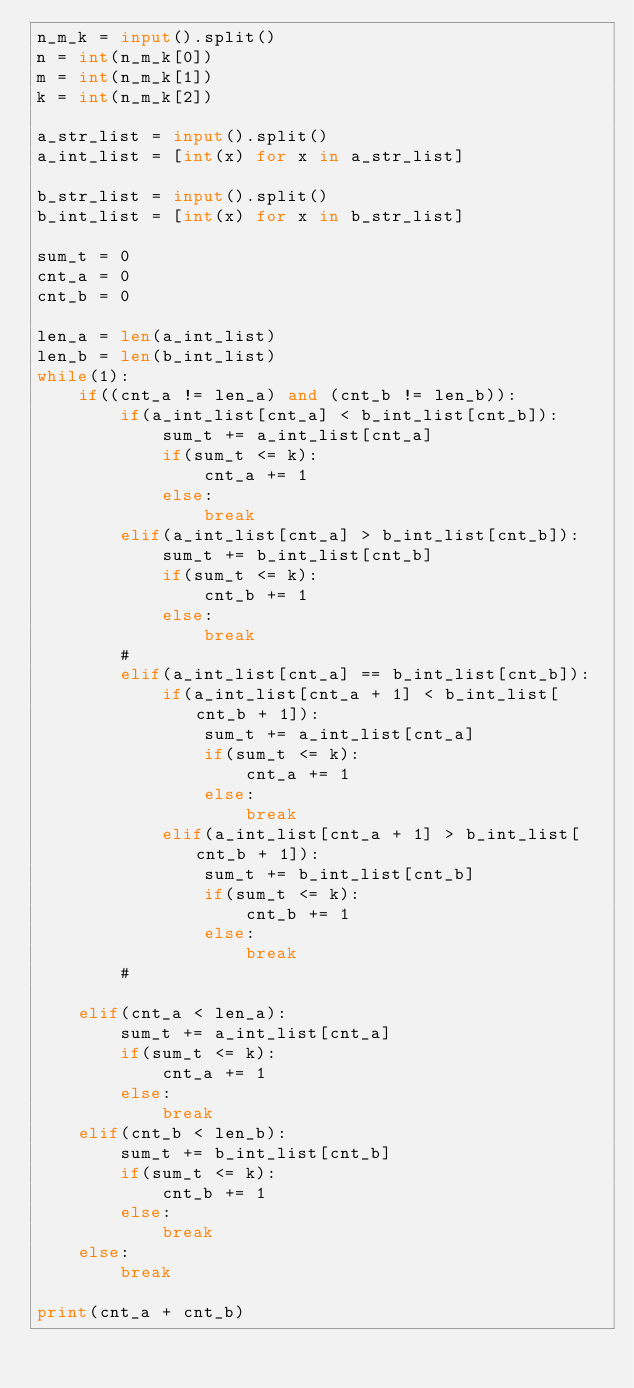<code> <loc_0><loc_0><loc_500><loc_500><_Python_>n_m_k = input().split()
n = int(n_m_k[0])
m = int(n_m_k[1])
k = int(n_m_k[2])

a_str_list = input().split()
a_int_list = [int(x) for x in a_str_list]

b_str_list = input().split()
b_int_list = [int(x) for x in b_str_list]

sum_t = 0
cnt_a = 0
cnt_b = 0

len_a = len(a_int_list)
len_b = len(b_int_list)
while(1):
    if((cnt_a != len_a) and (cnt_b != len_b)):
        if(a_int_list[cnt_a] < b_int_list[cnt_b]):
            sum_t += a_int_list[cnt_a]
            if(sum_t <= k):
                cnt_a += 1
            else:
                break
        elif(a_int_list[cnt_a] > b_int_list[cnt_b]):
            sum_t += b_int_list[cnt_b]
            if(sum_t <= k):
                cnt_b += 1
            else:
                break
        #
        elif(a_int_list[cnt_a] == b_int_list[cnt_b]):
            if(a_int_list[cnt_a + 1] < b_int_list[cnt_b + 1]):
                sum_t += a_int_list[cnt_a]
                if(sum_t <= k):
                    cnt_a += 1
                else:
                    break
            elif(a_int_list[cnt_a + 1] > b_int_list[cnt_b + 1]):
                sum_t += b_int_list[cnt_b]
                if(sum_t <= k):
                    cnt_b += 1
                else:
                    break
        #

    elif(cnt_a < len_a):
        sum_t += a_int_list[cnt_a]
        if(sum_t <= k):
            cnt_a += 1
        else:
            break
    elif(cnt_b < len_b):
        sum_t += b_int_list[cnt_b]
        if(sum_t <= k):
            cnt_b += 1
        else:
            break
    else:
        break

print(cnt_a + cnt_b)</code> 